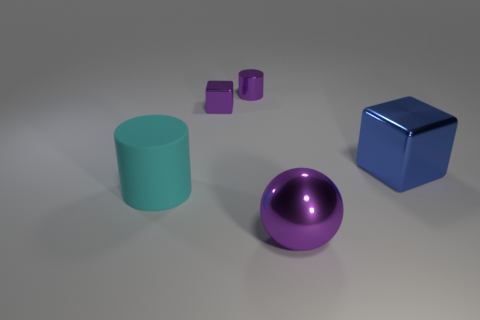Are there any other things that are the same shape as the big purple thing?
Give a very brief answer. No. There is a tiny shiny cube; does it have the same color as the metallic thing in front of the large cylinder?
Your answer should be very brief. Yes. What is the cylinder in front of the cube to the right of the tiny shiny thing in front of the metallic cylinder made of?
Your answer should be very brief. Rubber. What is the shape of the metallic thing that is in front of the big blue shiny block?
Keep it short and to the point. Sphere. What size is the purple block that is the same material as the big purple object?
Your answer should be very brief. Small. There is a cube to the left of the large purple metallic object; is it the same color as the big ball?
Make the answer very short. Yes. There is a metallic cube behind the shiny block that is right of the purple sphere; how many cyan matte things are behind it?
Make the answer very short. 0. How many objects are both behind the cyan matte object and in front of the small purple metal cube?
Your answer should be very brief. 1. There is a small metal thing that is the same color as the metallic cylinder; what is its shape?
Make the answer very short. Cube. Is there anything else that is the same material as the large cyan cylinder?
Your answer should be very brief. No. 